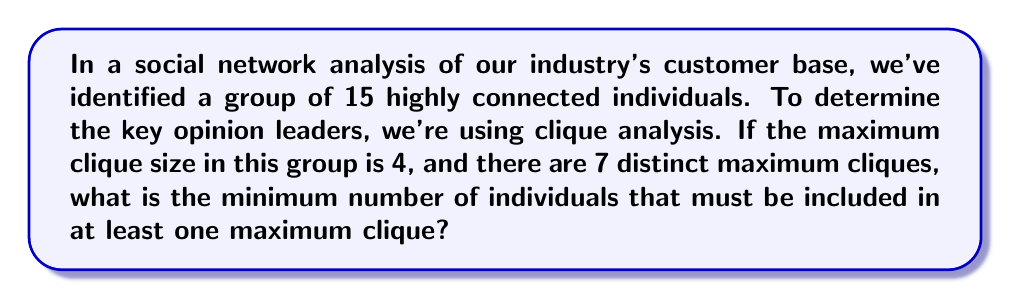Help me with this question. To solve this problem, we need to consider the following steps:

1) First, recall that a clique in graph theory is a subset of vertices of an undirected graph such that every two distinct vertices in the clique are adjacent.

2) We're told that the maximum clique size is 4, meaning each maximum clique contains 4 individuals.

3) There are 7 distinct maximum cliques in total.

4) To minimize the number of individuals involved, we want to maximize the overlap between these cliques.

5) Let's consider the extreme case where all cliques share 3 common individuals. In this scenario:
   - The 3 common individuals would be in all 7 cliques
   - Each of the 7 cliques would have one unique individual

6) So, the minimum number of individuals would be:
   $$ 3 + 7 = 10 $$

7) We can verify that this satisfies our conditions:
   - There are indeed 7 distinct cliques of size 4
   - No larger clique is possible, as adding any individual to the 3 common ones would only connect to at most 3 others

8) Therefore, the minimum number of individuals that must be included in at least one maximum clique is 10.
Answer: 10 individuals 